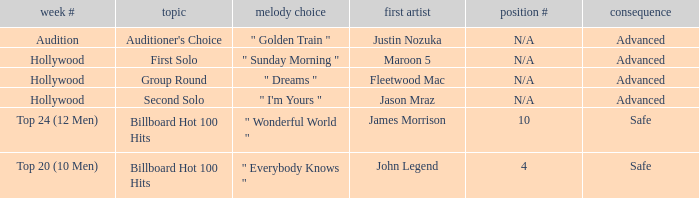In which week numbers does the subject matter involve the auditioner's choice? Audition. 